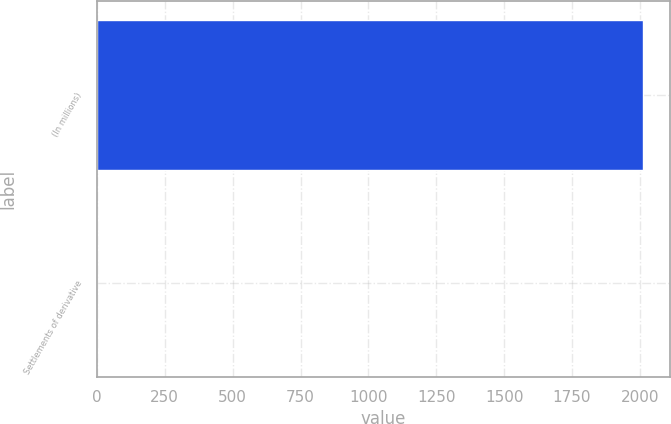Convert chart to OTSL. <chart><loc_0><loc_0><loc_500><loc_500><bar_chart><fcel>(In millions)<fcel>Settlements of derivative<nl><fcel>2011<fcel>2<nl></chart> 